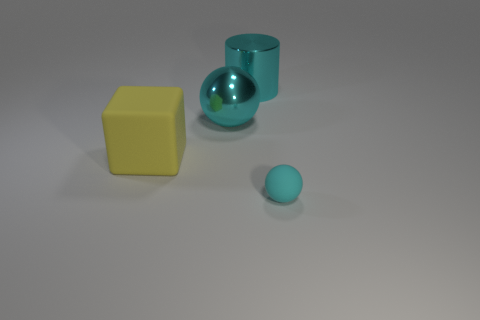Add 3 big red objects. How many objects exist? 7 Subtract all blocks. How many objects are left? 3 Subtract 0 cyan cubes. How many objects are left? 4 Subtract all big green matte cylinders. Subtract all spheres. How many objects are left? 2 Add 1 cyan matte objects. How many cyan matte objects are left? 2 Add 3 purple cylinders. How many purple cylinders exist? 3 